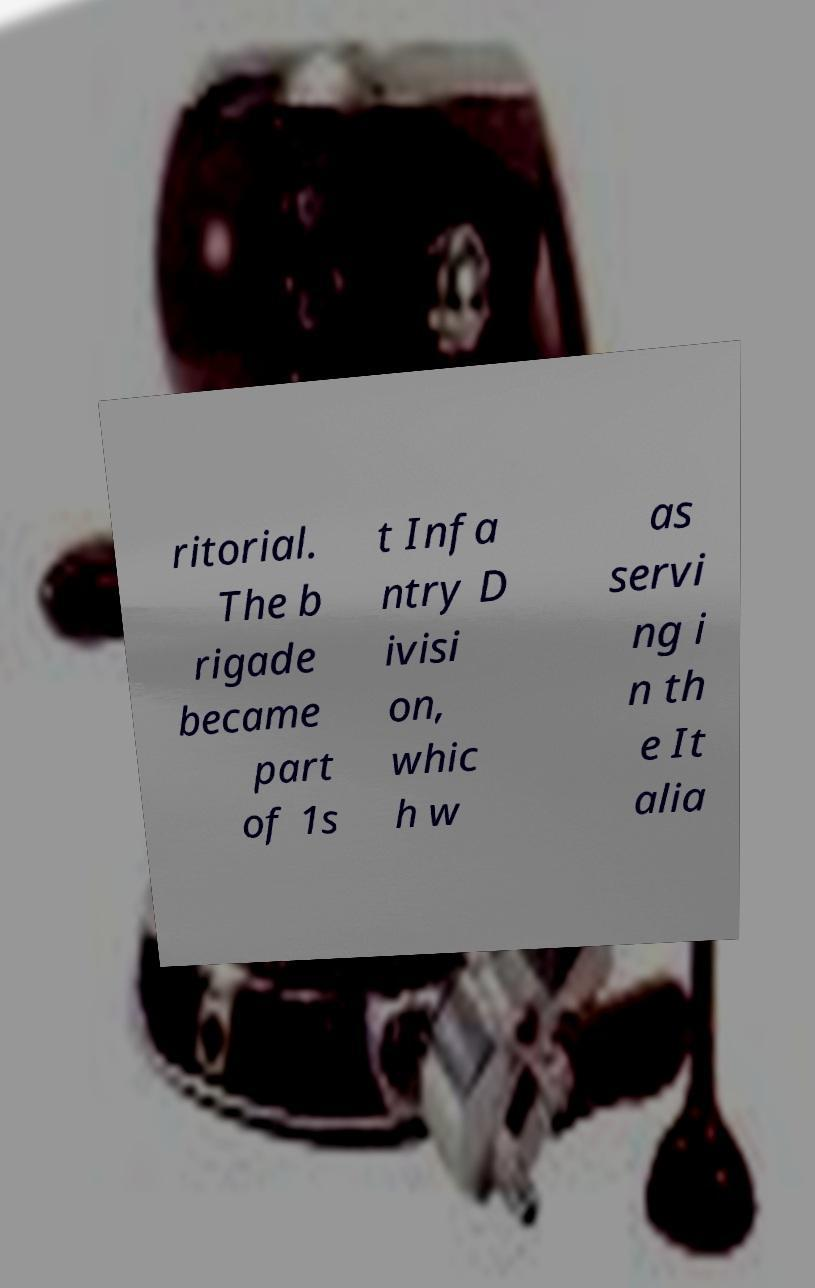For documentation purposes, I need the text within this image transcribed. Could you provide that? ritorial. The b rigade became part of 1s t Infa ntry D ivisi on, whic h w as servi ng i n th e It alia 